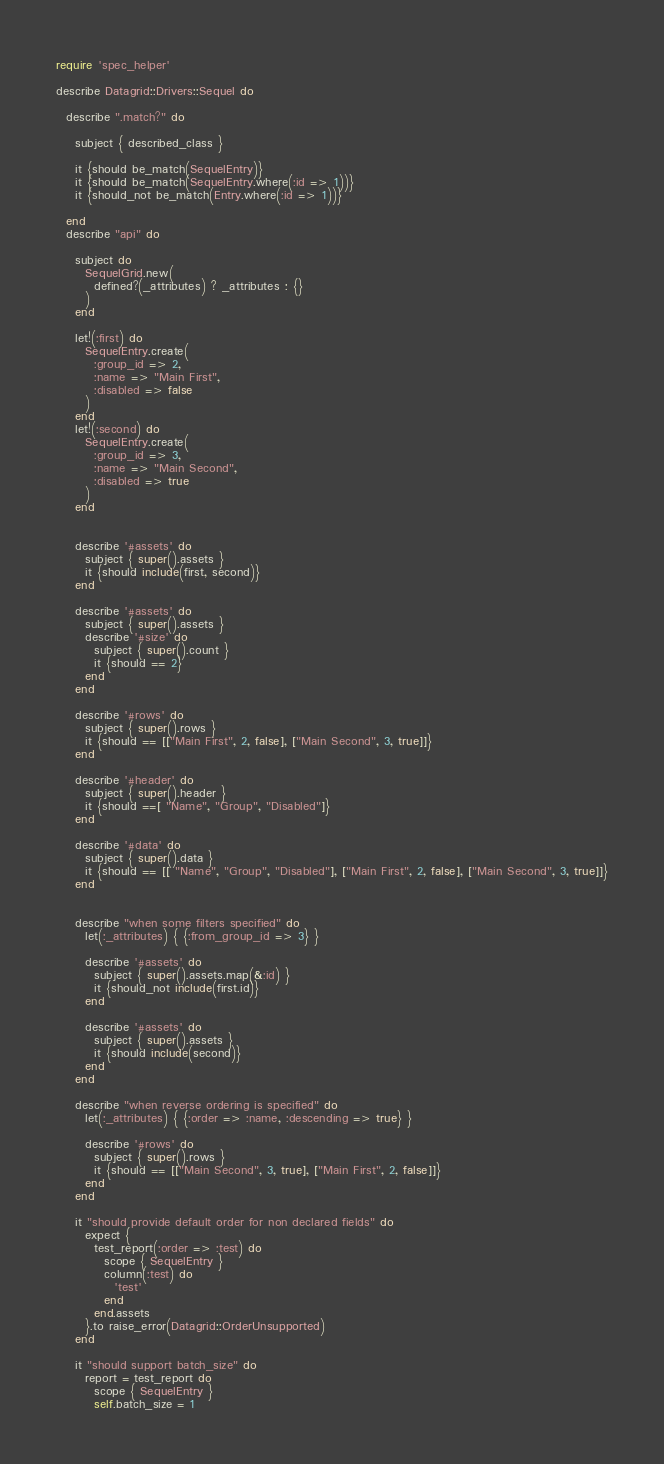Convert code to text. <code><loc_0><loc_0><loc_500><loc_500><_Ruby_>require 'spec_helper'

describe Datagrid::Drivers::Sequel do

  describe ".match?" do
    
    subject { described_class }

    it {should be_match(SequelEntry)}
    it {should be_match(SequelEntry.where(:id => 1))}
    it {should_not be_match(Entry.where(:id => 1))}

  end
  describe "api" do

    subject do
      SequelGrid.new(
        defined?(_attributes) ? _attributes : {}
      )
    end

    let!(:first) do
      SequelEntry.create(
        :group_id => 2,
        :name => "Main First",
        :disabled => false
      )
    end
    let!(:second) do
      SequelEntry.create(
        :group_id => 3,
        :name => "Main Second",
        :disabled => true
      )
    end


    describe '#assets' do
      subject { super().assets }
      it {should include(first, second)}
    end

    describe '#assets' do
      subject { super().assets }
      describe '#size' do
        subject { super().count }
        it {should == 2}
      end
    end

    describe '#rows' do
      subject { super().rows }
      it {should == [["Main First", 2, false], ["Main Second", 3, true]]}
    end

    describe '#header' do
      subject { super().header }
      it {should ==[ "Name", "Group", "Disabled"]}
    end

    describe '#data' do
      subject { super().data }
      it {should == [[ "Name", "Group", "Disabled"], ["Main First", 2, false], ["Main Second", 3, true]]}
    end


    describe "when some filters specified" do
      let(:_attributes) { {:from_group_id => 3} }

      describe '#assets' do
        subject { super().assets.map(&:id) }
        it {should_not include(first.id)}
      end

      describe '#assets' do
        subject { super().assets }
        it {should include(second)}
      end
    end

    describe "when reverse ordering is specified" do
      let(:_attributes) { {:order => :name, :descending => true} }

      describe '#rows' do
        subject { super().rows }
        it {should == [["Main Second", 3, true], ["Main First", 2, false]]}
      end
    end

    it "should provide default order for non declared fields" do
      expect {
        test_report(:order => :test) do
          scope { SequelEntry }
          column(:test) do
            'test'
          end
        end.assets
      }.to raise_error(Datagrid::OrderUnsupported)
    end

    it "should support batch_size" do
      report = test_report do
        scope { SequelEntry }
        self.batch_size = 1 </code> 